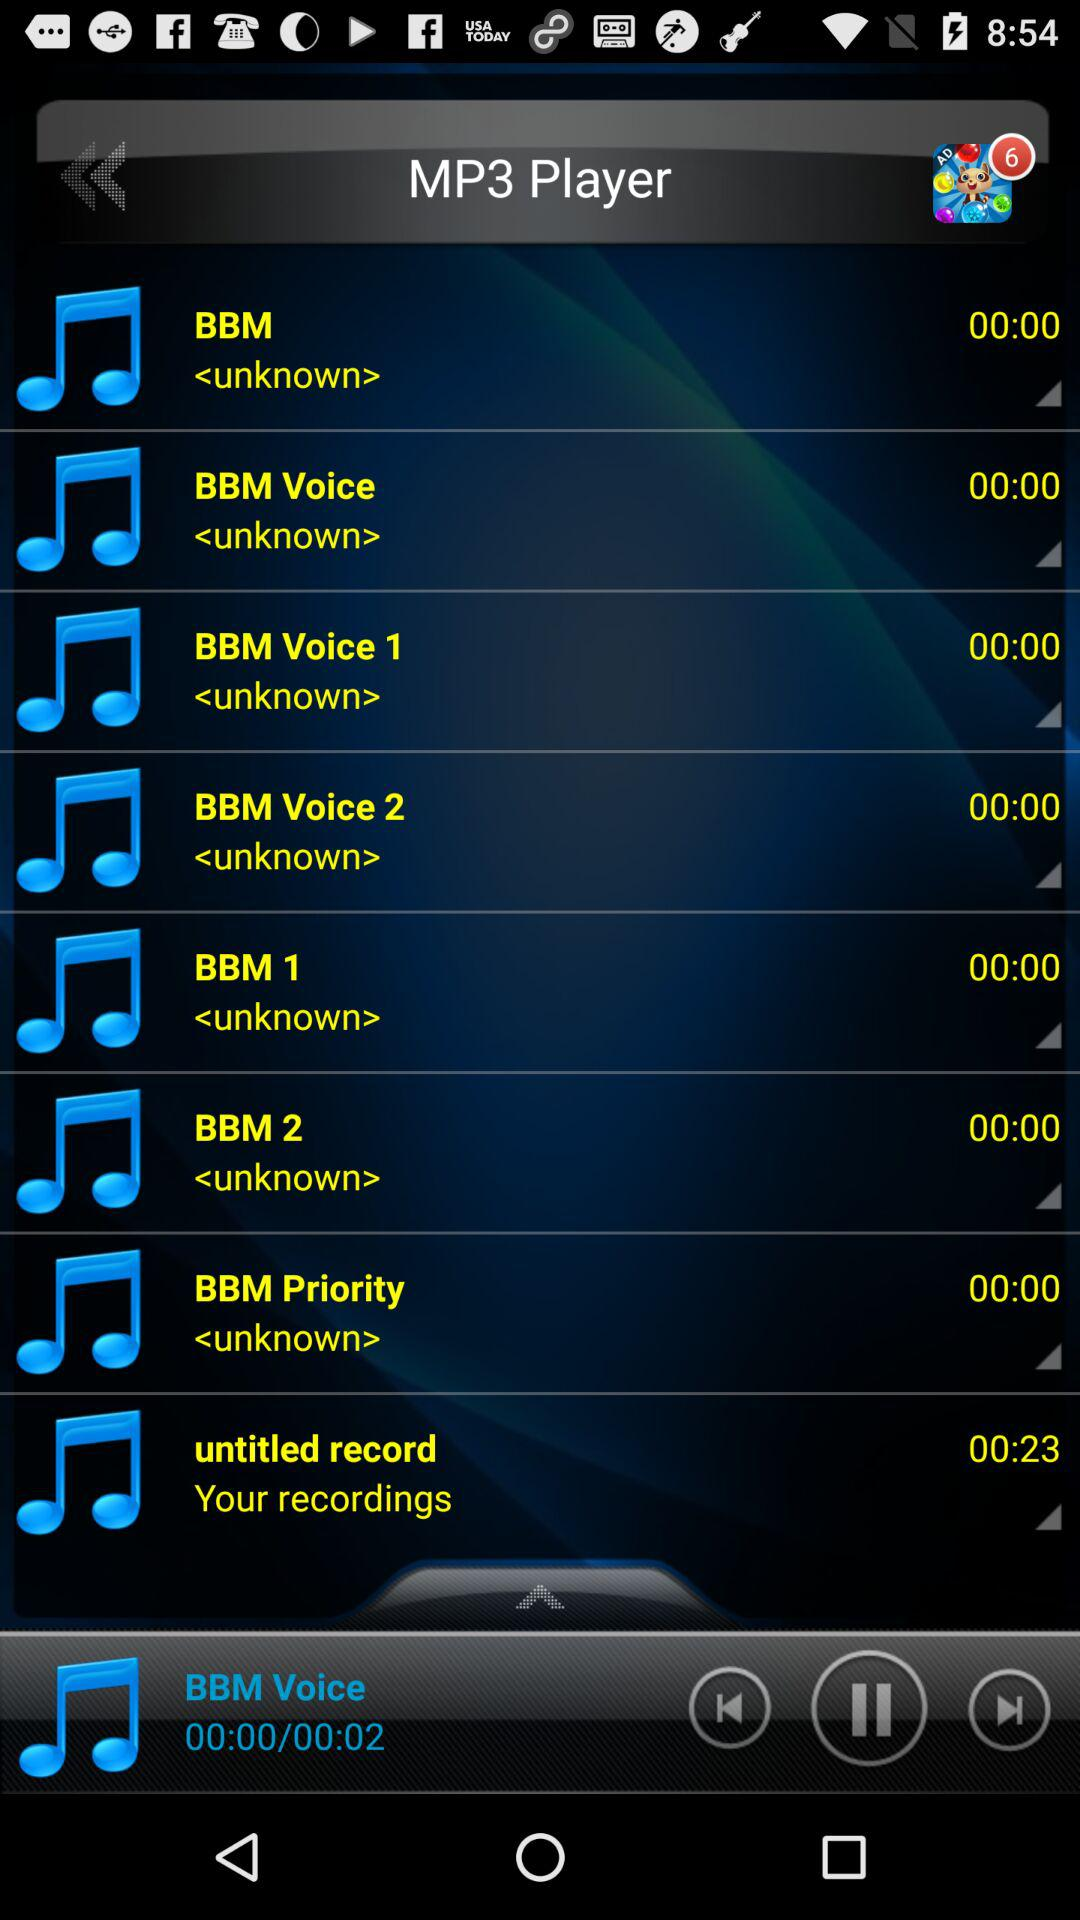What is the duration of "untitled record"? The duration of "untitled record" is 23 seconds. 